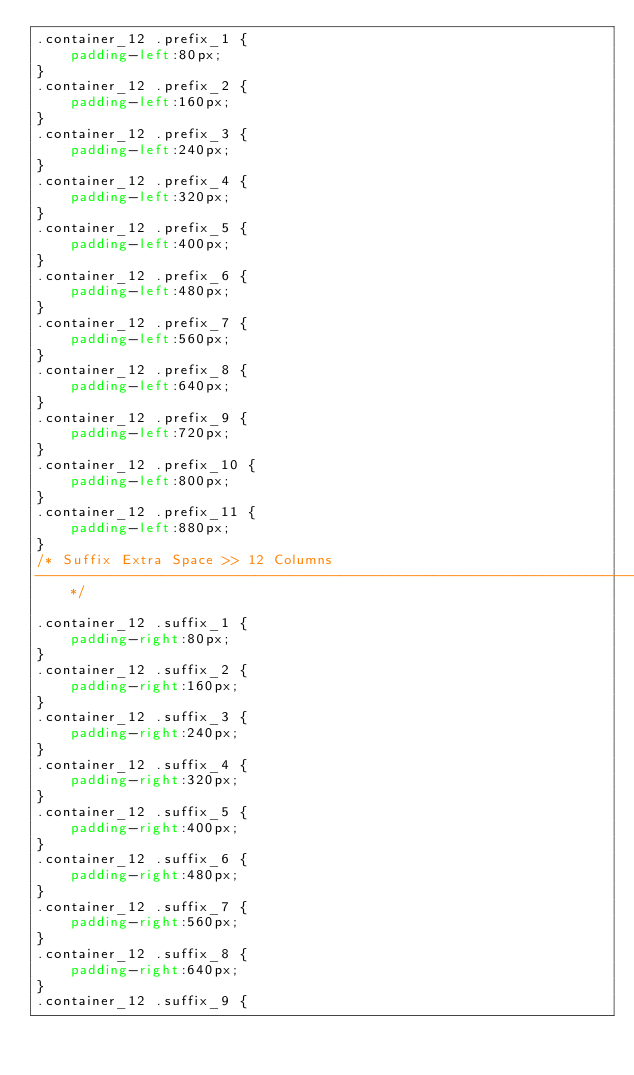Convert code to text. <code><loc_0><loc_0><loc_500><loc_500><_CSS_>.container_12 .prefix_1 {
	padding-left:80px;
}
.container_12 .prefix_2 {
	padding-left:160px;
}
.container_12 .prefix_3 {
	padding-left:240px;
}
.container_12 .prefix_4 {
	padding-left:320px;
}
.container_12 .prefix_5 {
	padding-left:400px;
}
.container_12 .prefix_6 {
	padding-left:480px;
}
.container_12 .prefix_7 {
	padding-left:560px;
}
.container_12 .prefix_8 {
	padding-left:640px;
}
.container_12 .prefix_9 {
	padding-left:720px;
}
.container_12 .prefix_10 {
	padding-left:800px;
}
.container_12 .prefix_11 {
	padding-left:880px;
}
/* Suffix Extra Space >> 12 Columns
----------------------------------------------------------------------------------------------------*/

.container_12 .suffix_1 {
	padding-right:80px;
}
.container_12 .suffix_2 {
	padding-right:160px;
}
.container_12 .suffix_3 {
	padding-right:240px;
}
.container_12 .suffix_4 {
	padding-right:320px;
}
.container_12 .suffix_5 {
	padding-right:400px;
}
.container_12 .suffix_6 {
	padding-right:480px;
}
.container_12 .suffix_7 {
	padding-right:560px;
}
.container_12 .suffix_8 {
	padding-right:640px;
}
.container_12 .suffix_9 {</code> 